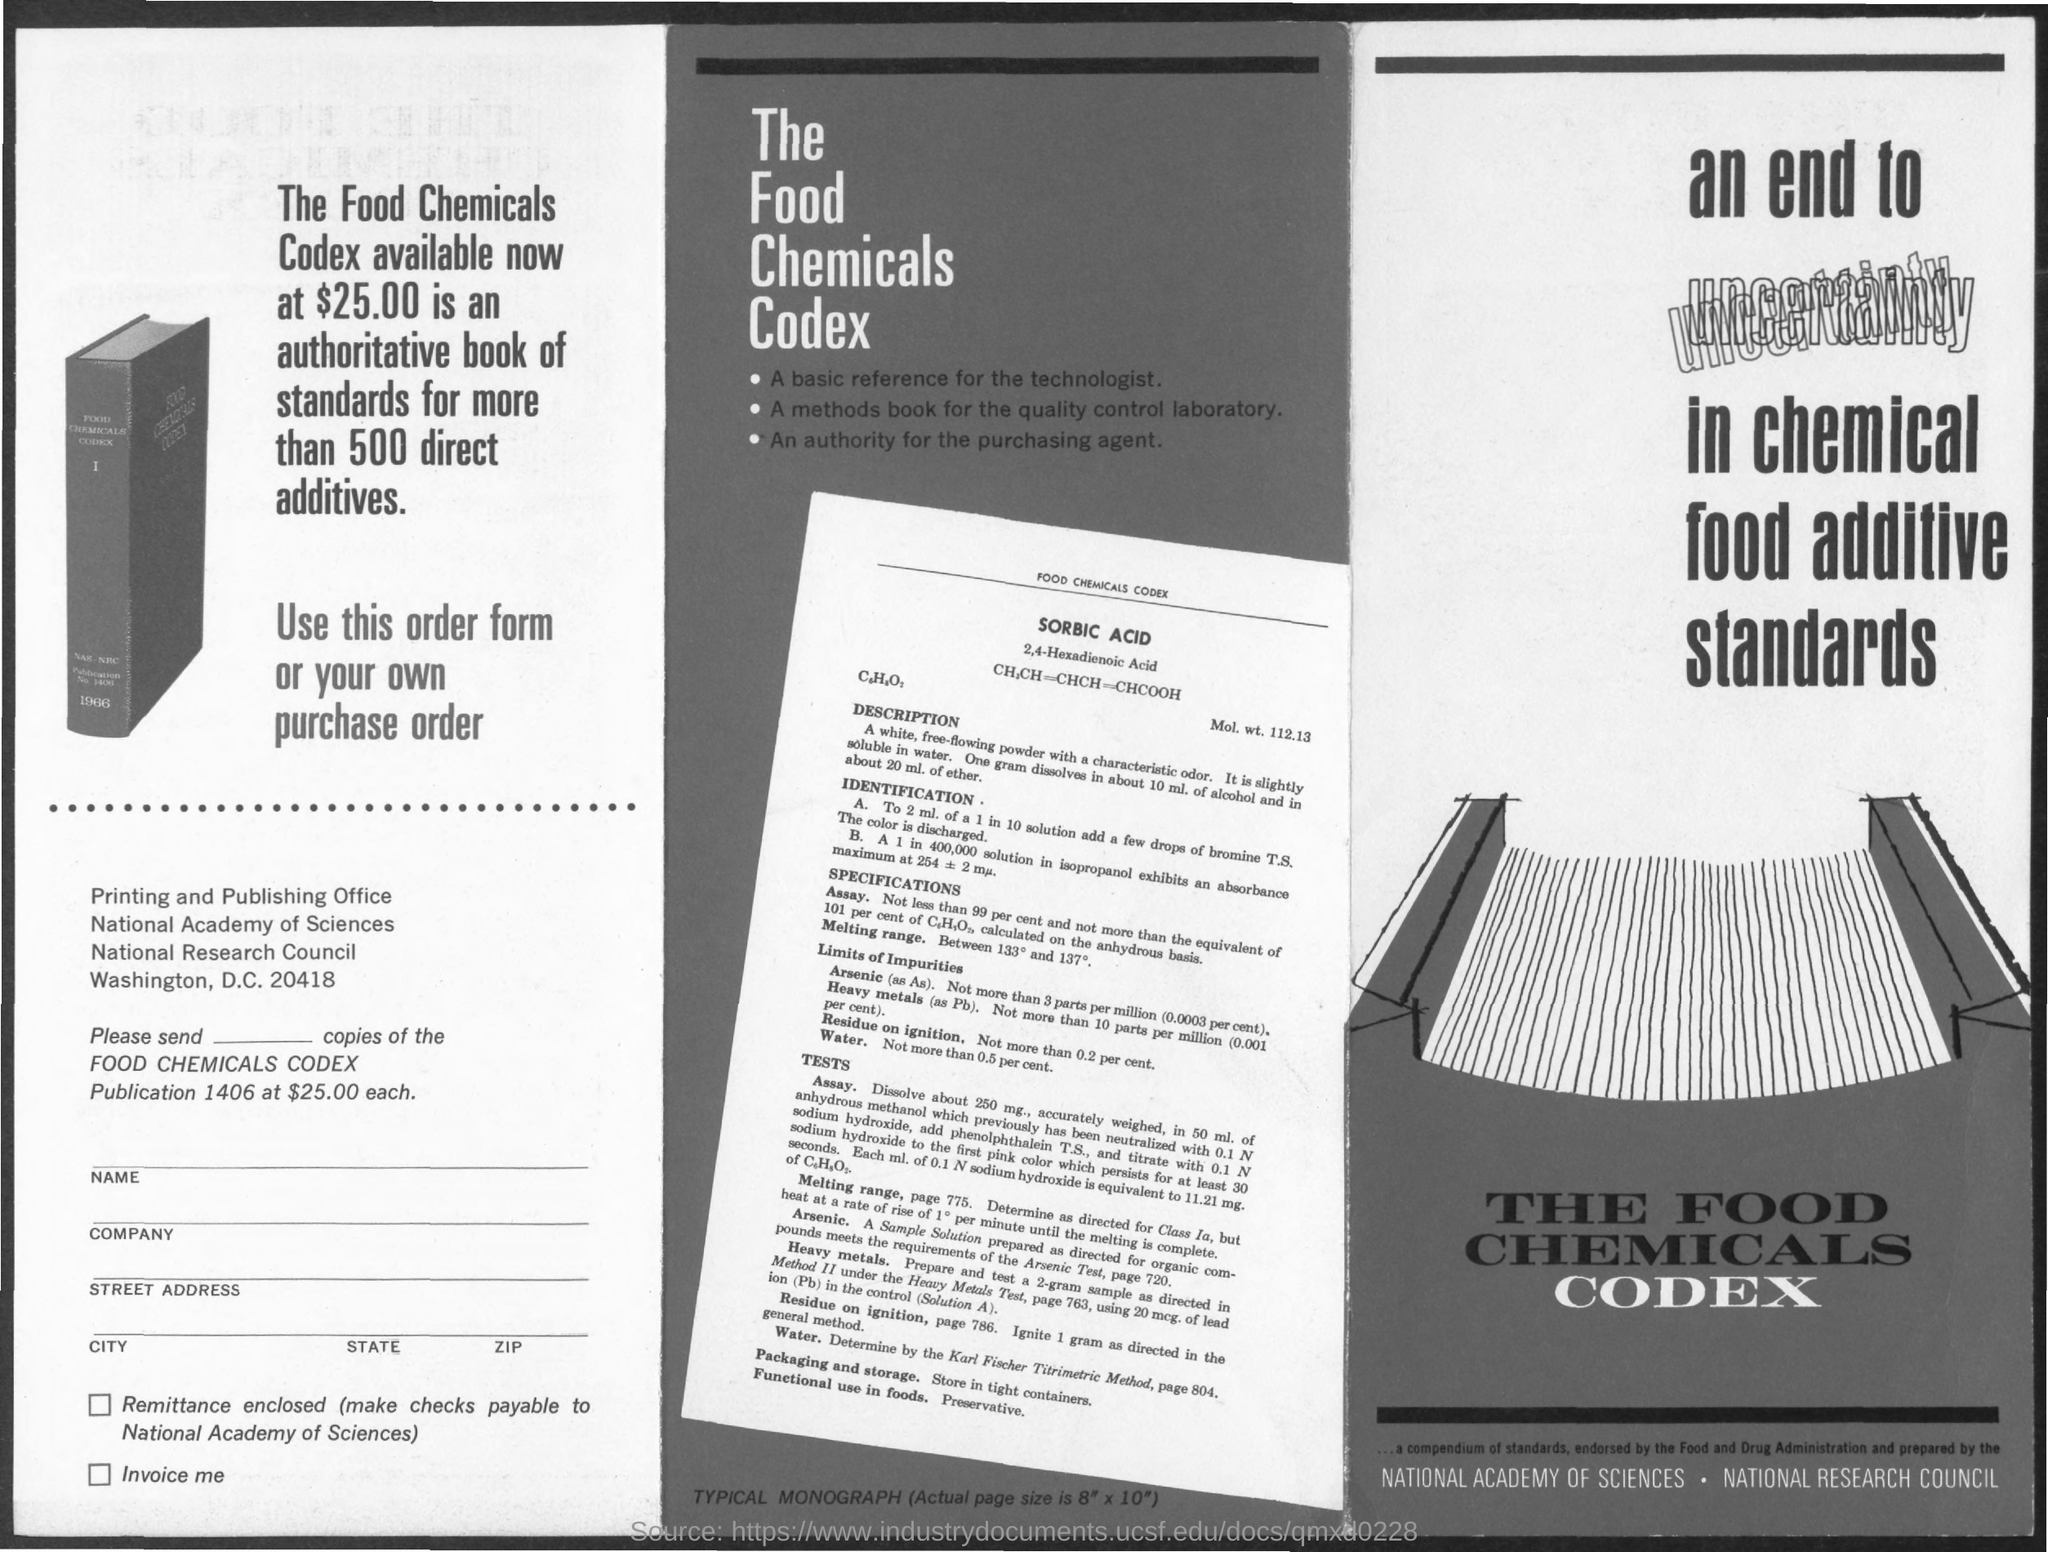What is the cost of food chemicals codex ?
Make the answer very short. $25.00. What kind of acid is mentioned in the chemical codex ?
Your answer should be compact. SORBIC ACID. 